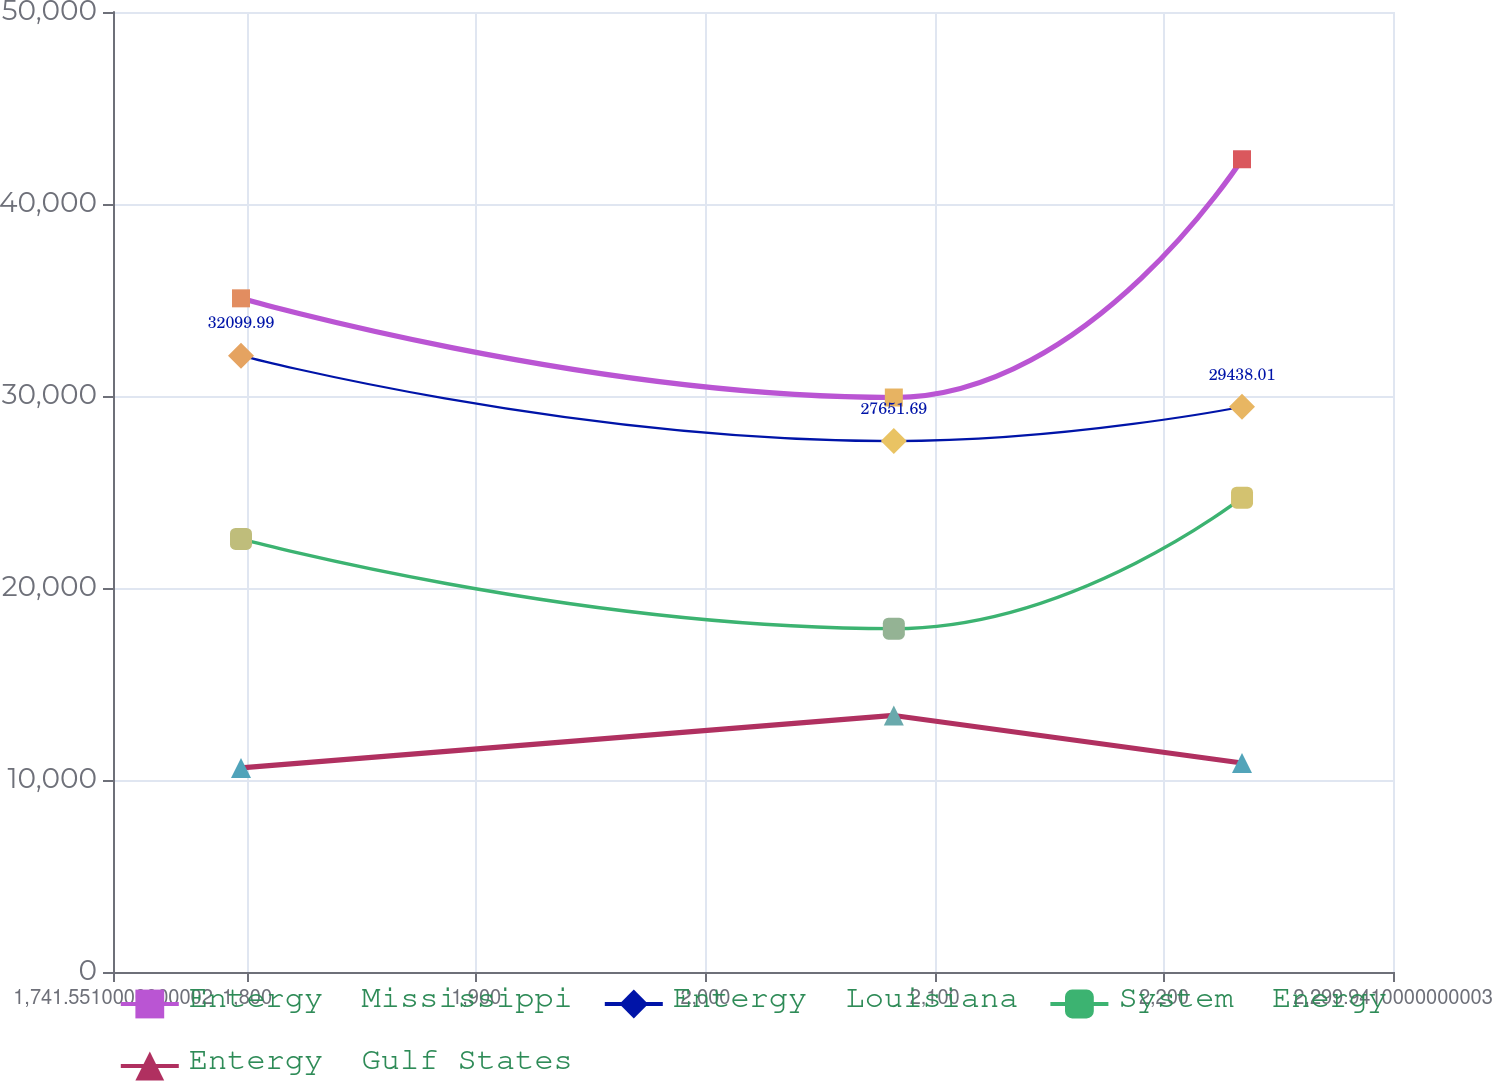<chart> <loc_0><loc_0><loc_500><loc_500><line_chart><ecel><fcel>Entergy  Mississippi<fcel>Entergy  Louisiana<fcel>System  Energy<fcel>Entergy  Gulf States<nl><fcel>1797.39<fcel>35086.9<fcel>32100<fcel>22557<fcel>10626.9<nl><fcel>2082.18<fcel>29921.3<fcel>27651.7<fcel>17883.4<fcel>13361.1<nl><fcel>2234.08<fcel>42330.1<fcel>29438<fcel>24704.8<fcel>10887.8<nl><fcel>2302.98<fcel>33602.9<fcel>32580.7<fcel>24051.3<fcel>13100.2<nl><fcel>2355.78<fcel>43663.1<fcel>33061.4<fcel>23397.8<fcel>11854.8<nl></chart> 